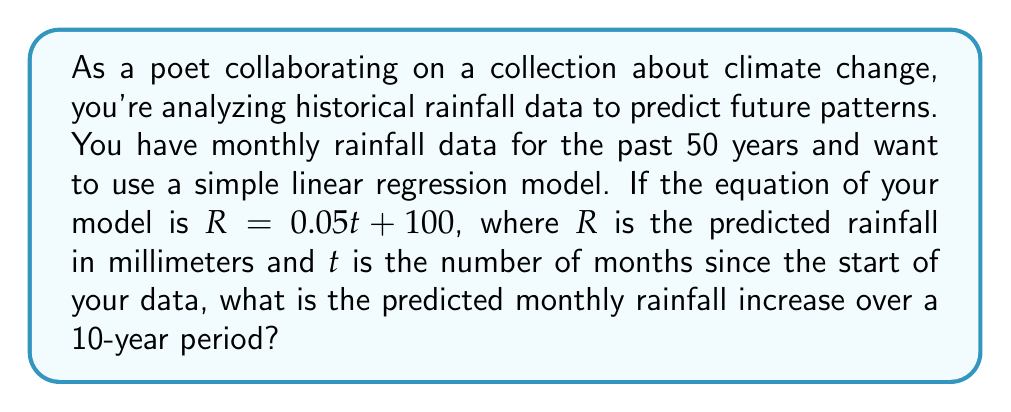Can you solve this math problem? To solve this problem, we'll follow these steps:

1) First, let's understand what the equation $R = 0.05t + 100$ means:
   - $R$ is the predicted rainfall in millimeters
   - $t$ is the number of months since the start of the data
   - 0.05 is the slope, representing the increase in rainfall per month
   - 100 is the y-intercept, representing the initial rainfall

2) We need to find the increase over a 10-year period. Let's convert 10 years to months:
   10 years = 10 * 12 = 120 months

3) Now, we can calculate the total increase over 120 months:
   Increase = Slope * Number of months
   Increase = 0.05 * 120 = 6 mm

4) However, the question asks for the monthly increase. To get this, we divide the total increase by the number of months in a year:
   Monthly increase = Total increase / 12
   Monthly increase = 6 / 12 = 0.5 mm

Therefore, the predicted monthly rainfall increase over a 10-year period is 0.5 mm.
Answer: 0.5 mm 